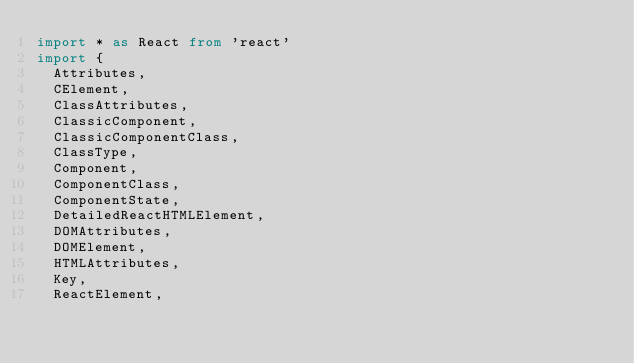Convert code to text. <code><loc_0><loc_0><loc_500><loc_500><_TypeScript_>import * as React from 'react'
import {
  Attributes,
  CElement,
  ClassAttributes,
  ClassicComponent,
  ClassicComponentClass,
  ClassType,
  Component,
  ComponentClass,
  ComponentState,
  DetailedReactHTMLElement,
  DOMAttributes,
  DOMElement,
  HTMLAttributes,
  Key,
  ReactElement,</code> 